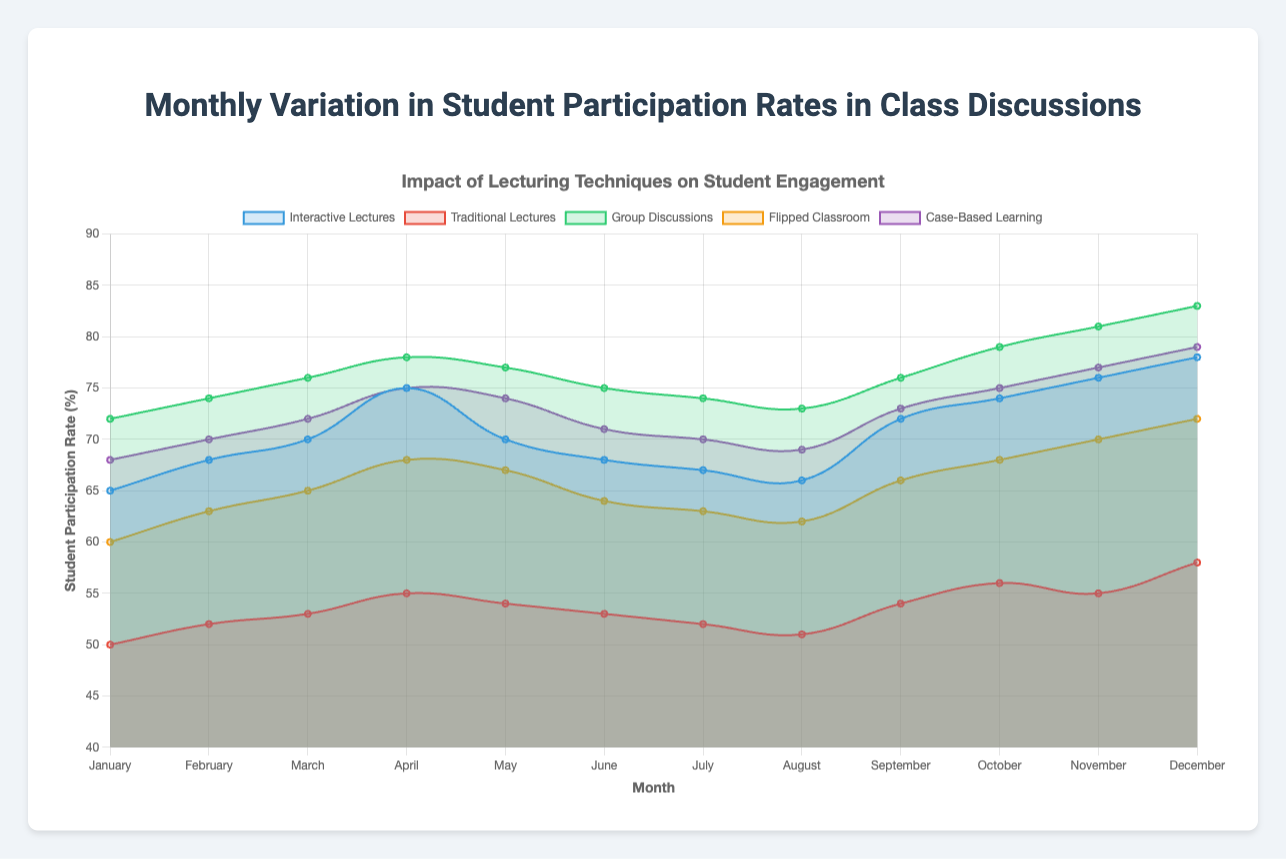What is the highest student participation rate for "Group Discussions" and in which month does it occur? The highest student participation rate for "Group Discussions" is 83%, which occurs in December. You need to refer to the data line for "Group Discussions" and identify the peak value and the corresponding month.
Answer: 83%, December Which lecturing technique shows the lowest student participation rate in February, and what is the rate? Looking at the participation rates in February, "Traditional Lectures" has the lowest rate with 52%. This is determined by comparing participation rates for all techniques in the month of February.
Answer: Traditional Lectures, 52% What is the average student participation rate for "Interactive Lectures" over the first half of the year (January to June)? To find the average, sum the participation rates for "Interactive Lectures" from January to June: 65 + 68 + 70 + 75 + 70 + 68 = 416. Then divide by 6 (number of months): 416/6 ≈ 69.33.
Answer: 69.33% Compare the participation rates for "Flipped Classroom" and "Case-Based Learning" in August. Which technique reports higher engagement? Comparing the rates in August, "Flipped Classroom" has a rate of 62%, while "Case-Based Learning" has a rate of 69%. Thus, "Case-Based Learning" reports higher engagement by 7 percentage points.
Answer: Case-Based Learning By how much does the student participation rate for "Traditional Lectures" increase from January to December? The participation rate for "Traditional Lectures" in January is 50% and in December it is 58%. The increase is calculated by: 58 - 50 = 8 percentage points.
Answer: 8 percentage points Among all lecturing techniques, which one exhibits the most consistent student participation rate throughout the year? To find the most consistent technique, observe the variability in the rates for each technique. "Traditional Lectures" shows the smallest range (58% - 50% = 8%) indicating the most consistency.
Answer: Traditional Lectures What month shows the highest overall student participation rate, considering all lecturing techniques? To determine this, compare the highest values each month from all techniques. December has high rates across "Group Discussions" (83%), "Interactive Lectures" (78%), and "Case-Based Learning" (79%), marking it as the highest overall.
Answer: December How does the trend in student participation rates for "Interactive Lectures" change from summer (June-August) to fall (September-November)? In "Interactive Lectures," June-August rates are 68%, 67%, 66%, respectively, showing a slight decrease. Whereas September-November rates are 72%, 74%, 76%, respectively, indicating an increasing trend.
Answer: Decreasing in summer, Increasing in fall What is the difference in student participation rates between "Group Discussions" and "Flipped Classroom" in March? For March, "Group Discussions" has a rate of 76%, and "Flipped Classroom" has 65%. The difference is calculated by: 76 - 65 = 11 percentage points.
Answer: 11 percentage points 